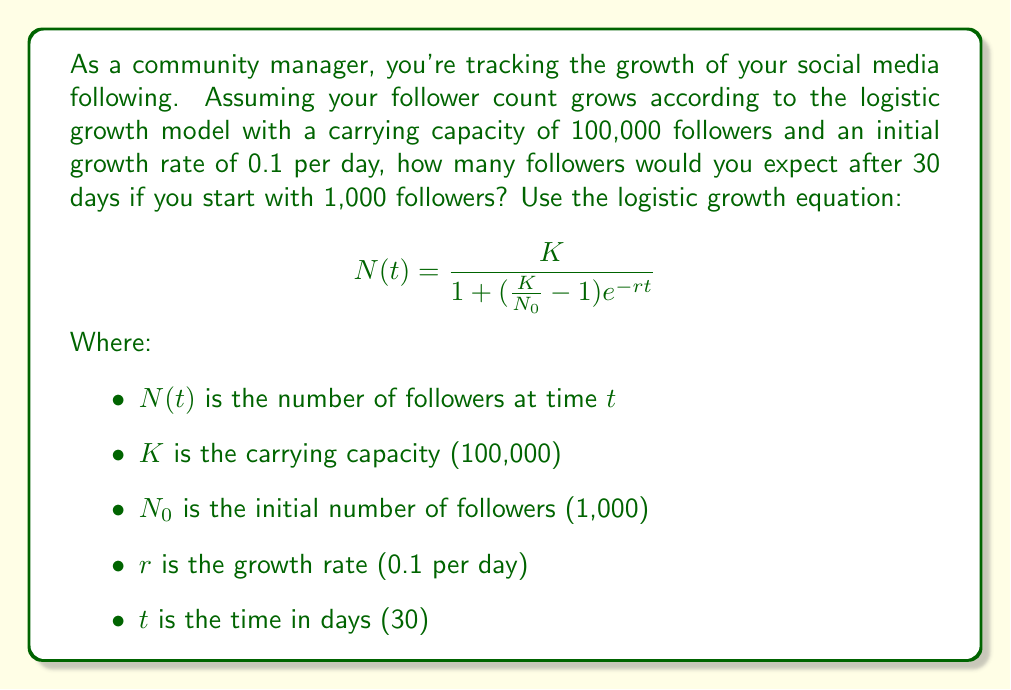Provide a solution to this math problem. To solve this problem, we'll use the logistic growth equation and plug in the given values:

1) First, let's identify our variables:
   $K = 100,000$
   $N_0 = 1,000$
   $r = 0.1$
   $t = 30$

2) Now, let's substitute these values into the equation:

   $$N(30) = \frac{100,000}{1 + (\frac{100,000}{1,000} - 1)e^{-0.1 \cdot 30}}$$

3) Simplify the fraction inside the parentheses:
   
   $$N(30) = \frac{100,000}{1 + (99)e^{-3}}$$

4) Calculate $e^{-3}$:
   
   $$N(30) = \frac{100,000}{1 + 99 \cdot 0.0497871}$$

5) Multiply:
   
   $$N(30) = \frac{100,000}{1 + 4.9289229}$$

6) Add:
   
   $$N(30) = \frac{100,000}{5.9289229}$$

7) Divide:
   
   $$N(30) = 16,866.95$$

8) Round to the nearest whole number (as we can't have fractional followers):
   
   $$N(30) \approx 16,867$$
Answer: 16,867 followers 